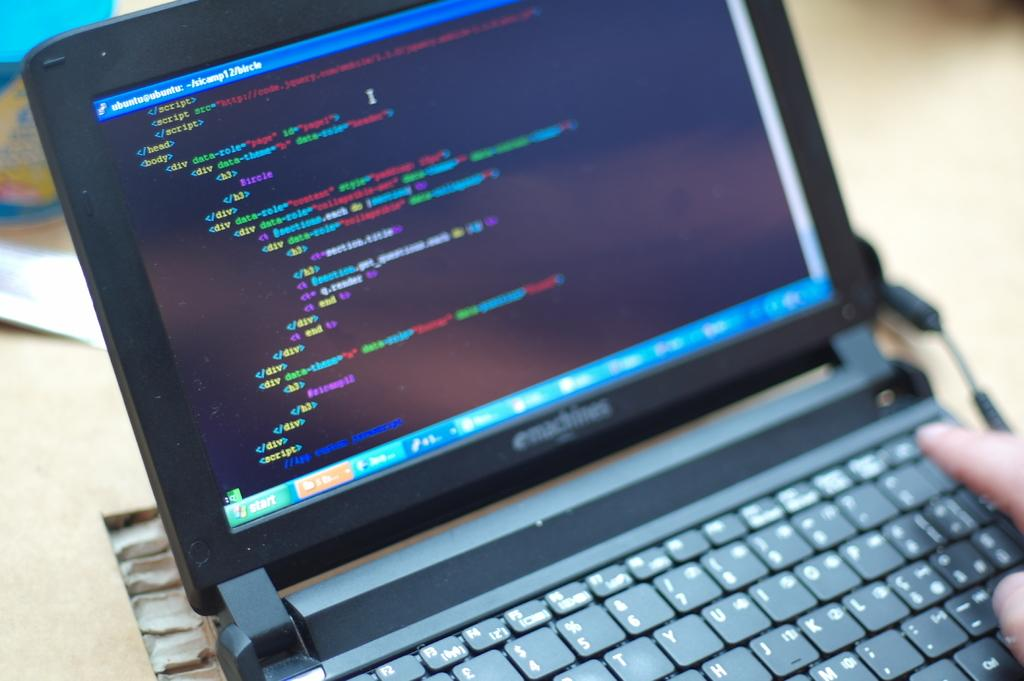Provide a one-sentence caption for the provided image. An emachines laptop is opened to a black text screen. 